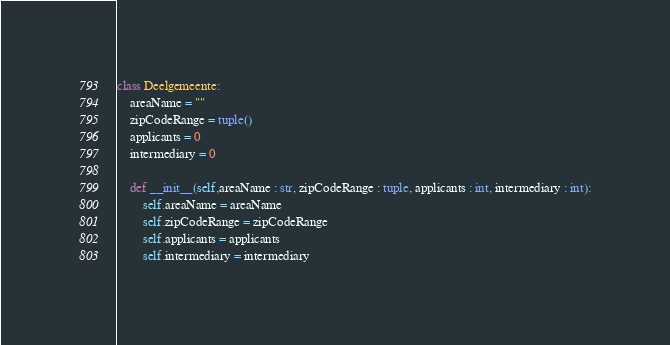<code> <loc_0><loc_0><loc_500><loc_500><_Python_>class Deelgemeente:
    areaName = ""
    zipCodeRange = tuple()
    applicants = 0
    intermediary = 0 

    def __init__(self,areaName : str, zipCodeRange : tuple, applicants : int, intermediary : int):
        self.areaName = areaName
        self.zipCodeRange = zipCodeRange
        self.applicants = applicants
        self.intermediary = intermediary</code> 